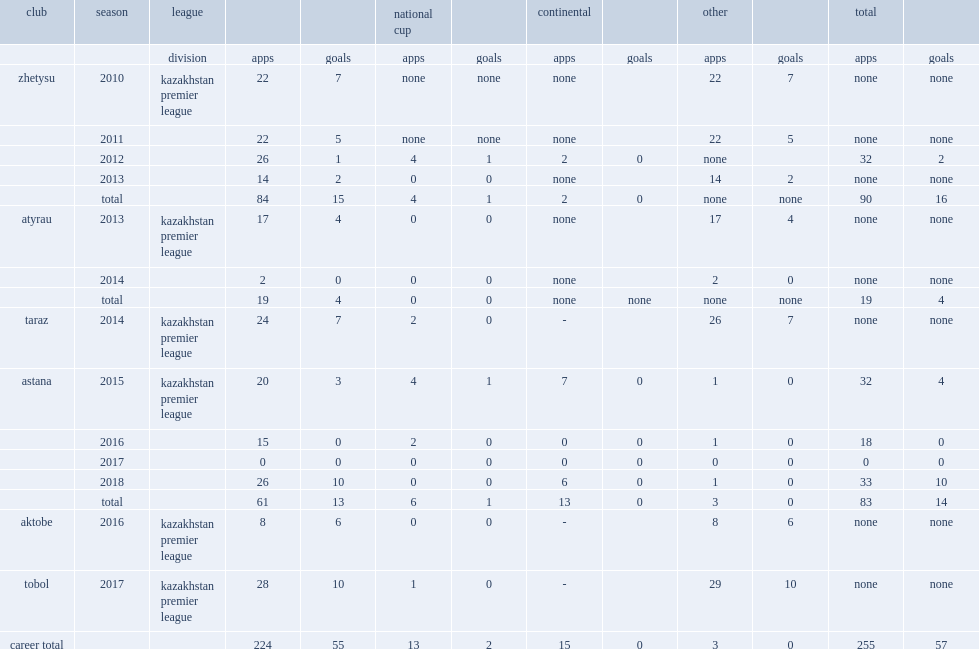Which club did shchotki play for in 2015? Astana. 